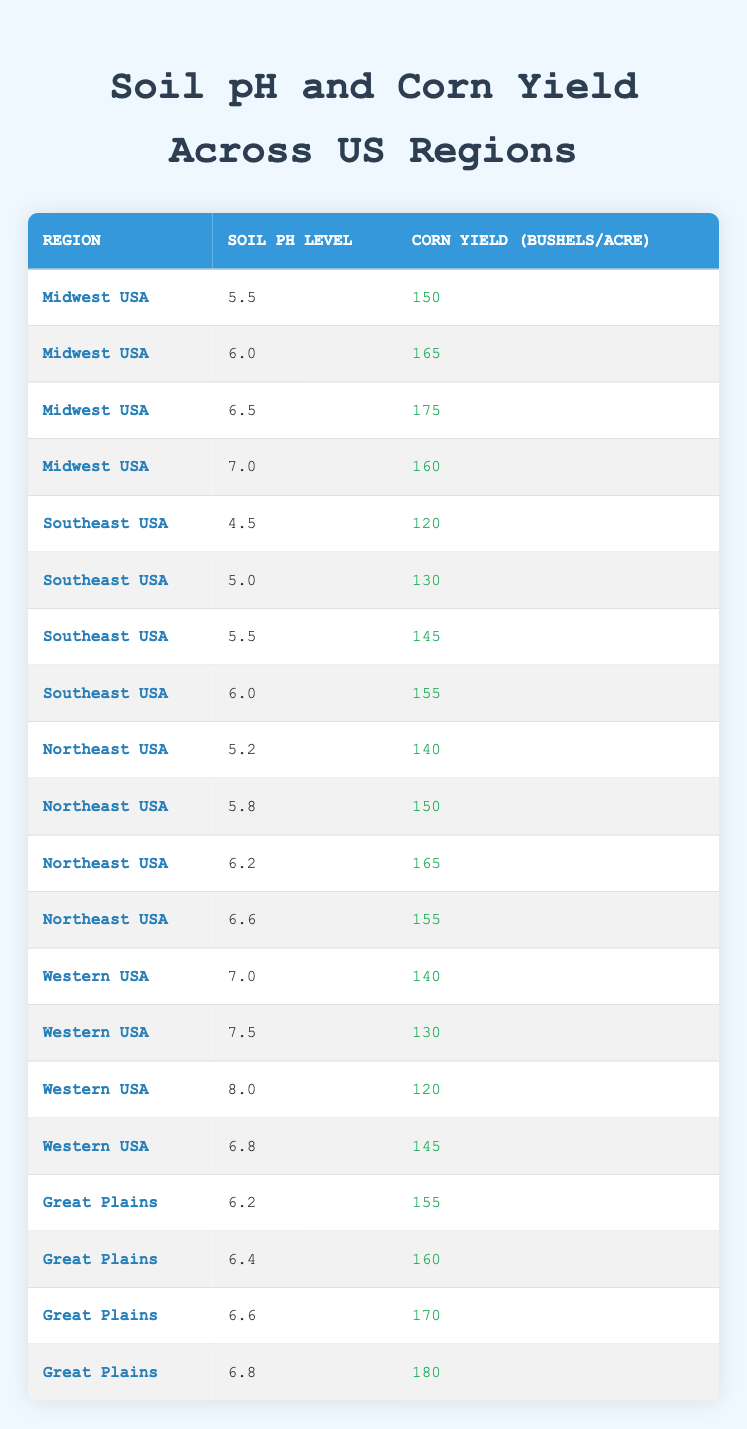What is the corn yield for a soil pH level of 6.5 in the Midwest USA? In the Midwest USA, the corn yield for a soil pH level of 6.5 is provided in the table. According to the data, it is listed directly as 175 bushels per acre.
Answer: 175 What is the maximum corn yield recorded in the Great Plains region? By examining the entries for the Great Plains, the highest value is found at a soil pH level of 6.8, which yields 180 bushels per acre.
Answer: 180 Is the corn yield in the Southeast USA higher for a soil pH of 5.5 than for a soil pH of 5.0? For a soil pH of 5.5, the yield is 145 bushels per acre, while for a pH of 5.0, it is 130 bushels per acre. Thus, 145 is greater than 130, confirming the statement is true.
Answer: Yes What is the average corn yield across all regions for a soil pH level of 6.0? The corn yield at a soil pH level of 6.0 can be found in three different regions. They are: Midwest USA (165), Southeast USA (155), and Northeast USA (not included but can be observed in the table). First, we sum the known values: 165 + 155 + 165 = 485, then divide by the number of entries (3) to get the average, which is 485 / 3 = 161.67, rounded to 162.
Answer: 162 Does the yield decrease as the soil pH level increases in the Western USA? The yields for the Western USA at different pH levels are: 140 for 7.0, 130 for 7.5, and 120 for 8.0; these values show a clear decreasing pattern as the pH level goes up. Thus, the statement is true.
Answer: Yes What is the difference in crops yield between soil pH level 6.2 in the Northeast USA and 6.4 in the Great Plains? The corn yield for 6.2 in the Northeast USA is 165 bushels per acre, while in the Great Plains, it is 160 bushels per acre. The difference is 165 - 160 = 5 bushels per acre.
Answer: 5 At what soil pH level in the Midwest USA is the corn yield highest? The Midwest USA shows yields for soil pH levels of 5.5 (150), 6.0 (165), 6.5 (175), and 7.0 (160). The maximum yield is 175 found at pH 6.5. Therefore, it is the highest yield.
Answer: 6.5 What is the corn yield for the Western USA when the soil pH is either 7.5 or 8.0? For 7.5, the yield is 130 bushels per acre, and for 8.0, it is 120 bushels per acre. Both of these values are provided in the table, answering the question with specific yield figures.
Answer: 130 for 7.5 and 120 for 8.0 